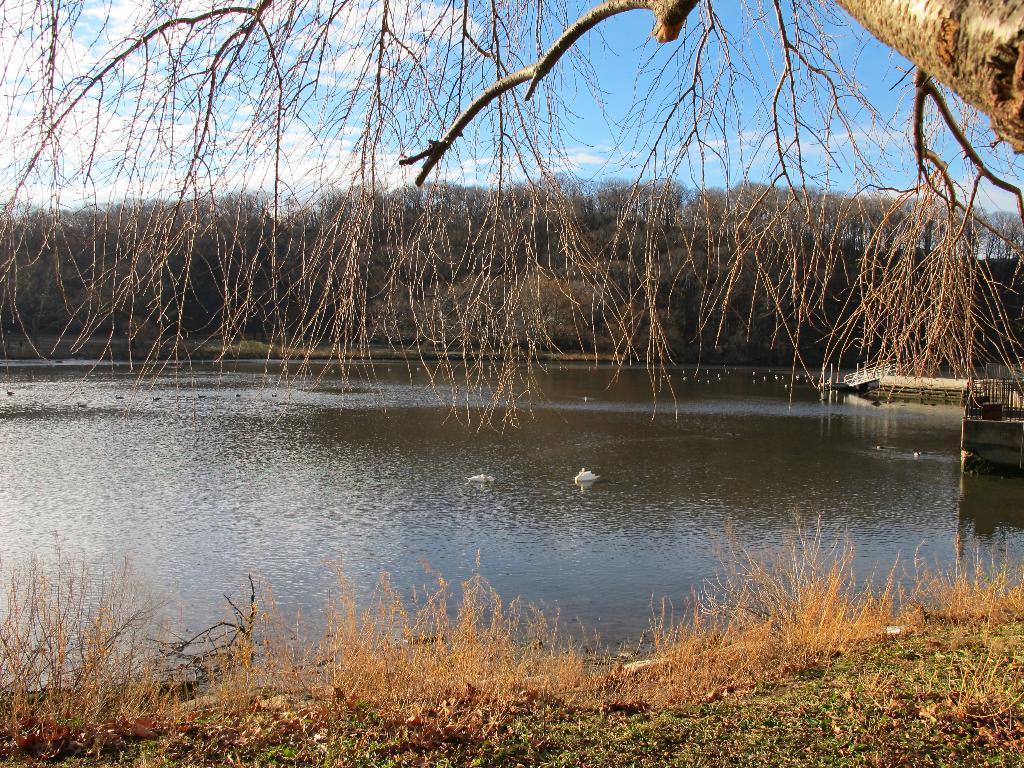Describe this image in one or two sentences. In this picture we can see water, trees, grass and in the background we can see the sky with clouds. 